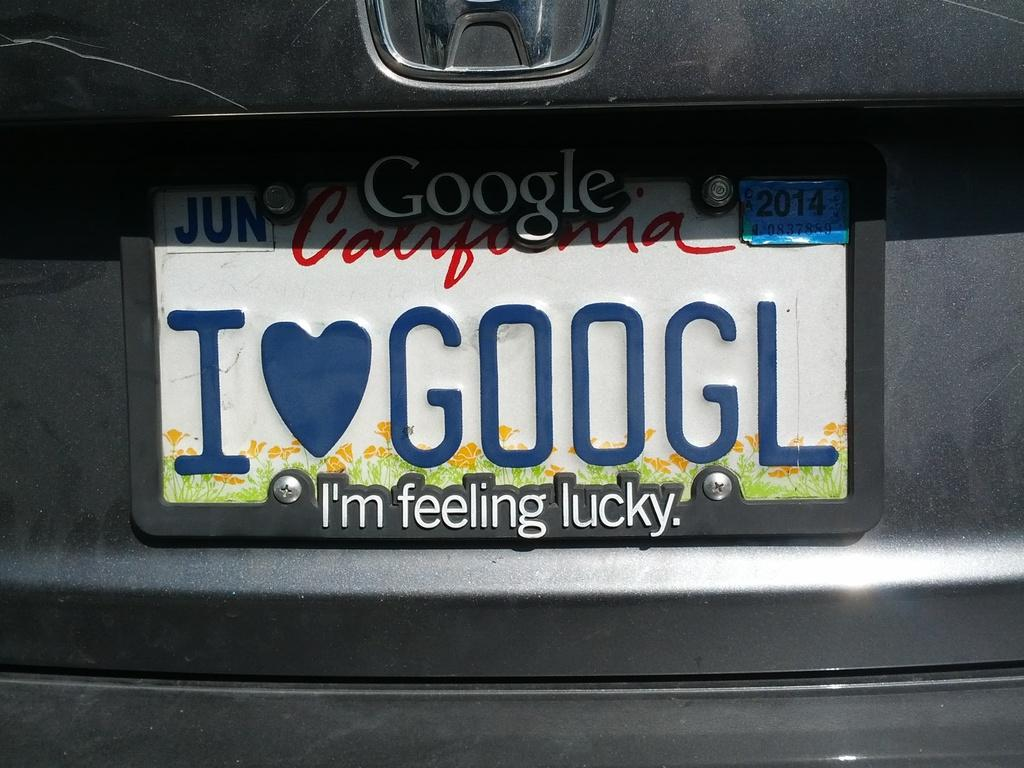<image>
Describe the image concisely. A Honda license plate that says I heart googl. 